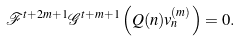<formula> <loc_0><loc_0><loc_500><loc_500>\mathcal { F } ^ { t + 2 m + 1 } \mathcal { G } ^ { t + m + 1 } \left ( Q ( n ) v _ { n } ^ { ( m ) } \right ) = 0 .</formula> 